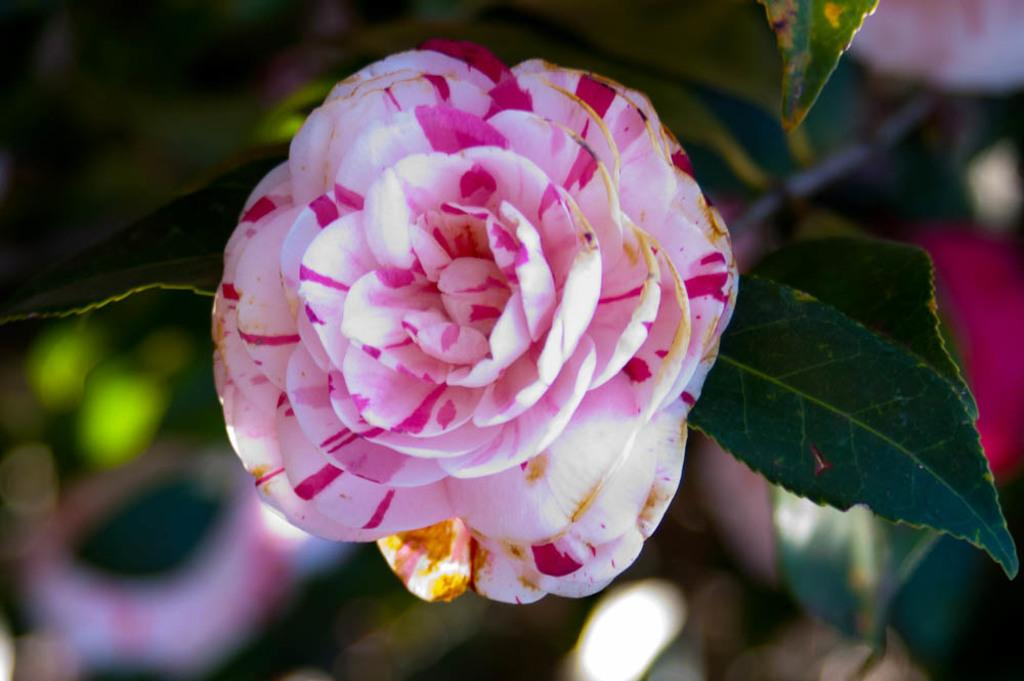What is the main subject of the picture? The main subject of the picture is a flower. Can you describe the colors of the flower? The flower has white, yellow, and pink colors. What else can be seen below the flower in the picture? There are leaves below the flower. What type of zinc can be seen in the picture? There is no zinc present in the picture; it features a flower with leaves. What kind of jewel is attached to the petals of the flower? There is no jewel present on the flower in the picture. 